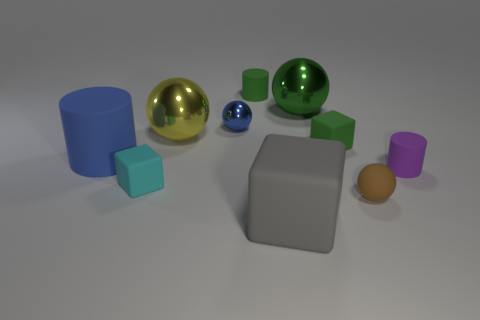Subtract all small cyan matte cubes. How many cubes are left? 2 Subtract all blue cylinders. How many cylinders are left? 2 Subtract 2 blocks. How many blocks are left? 1 Subtract all balls. How many objects are left? 6 Add 5 tiny shiny cubes. How many tiny shiny cubes exist? 5 Subtract 1 green balls. How many objects are left? 9 Subtract all green balls. Subtract all yellow blocks. How many balls are left? 3 Subtract all red metallic objects. Subtract all purple things. How many objects are left? 9 Add 7 big matte cylinders. How many big matte cylinders are left? 8 